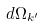<formula> <loc_0><loc_0><loc_500><loc_500>d \Omega _ { k ^ { \prime } }</formula> 